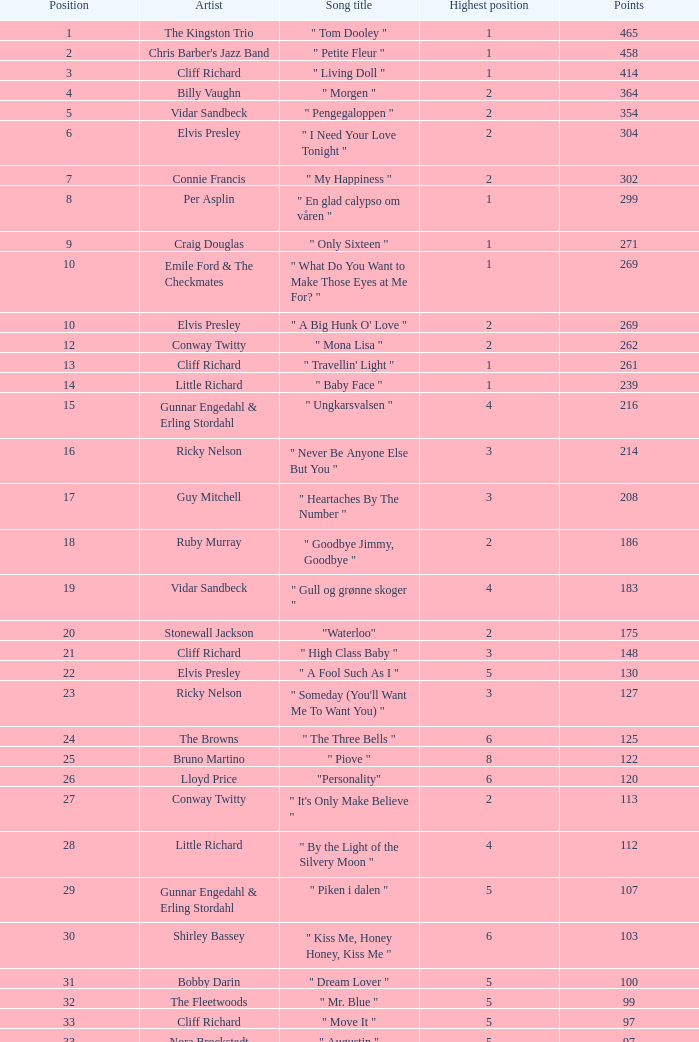What is the title of the song billy vaughn performed? " Morgen ". 